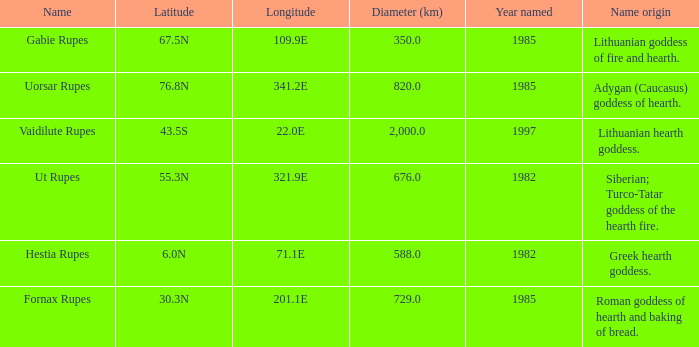Would you mind parsing the complete table? {'header': ['Name', 'Latitude', 'Longitude', 'Diameter (km)', 'Year named', 'Name origin'], 'rows': [['Gabie Rupes', '67.5N', '109.9E', '350.0', '1985', 'Lithuanian goddess of fire and hearth.'], ['Uorsar Rupes', '76.8N', '341.2E', '820.0', '1985', 'Adygan (Caucasus) goddess of hearth.'], ['Vaidilute Rupes', '43.5S', '22.0E', '2,000.0', '1997', 'Lithuanian hearth goddess.'], ['Ut Rupes', '55.3N', '321.9E', '676.0', '1982', 'Siberian; Turco-Tatar goddess of the hearth fire.'], ['Hestia Rupes', '6.0N', '71.1E', '588.0', '1982', 'Greek hearth goddess.'], ['Fornax Rupes', '30.3N', '201.1E', '729.0', '1985', 'Roman goddess of hearth and baking of bread.']]} At a latitude of 67.5n, what is the diameter? 350.0. 